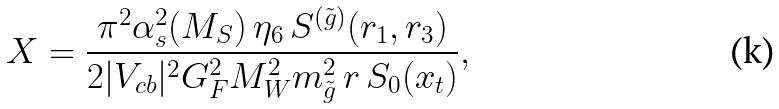<formula> <loc_0><loc_0><loc_500><loc_500>X = \frac { \pi ^ { 2 } \alpha _ { s } ^ { 2 } ( M _ { S } ) \, \eta _ { 6 } \, S ^ { ( \tilde { g } ) } ( r _ { 1 } , r _ { 3 } ) } { 2 | V _ { c b } | ^ { 2 } G _ { F } ^ { 2 } M _ { W } ^ { 2 } m ^ { 2 } _ { \tilde { g } } \, r \, S _ { 0 } ( x _ { t } ) } ,</formula> 